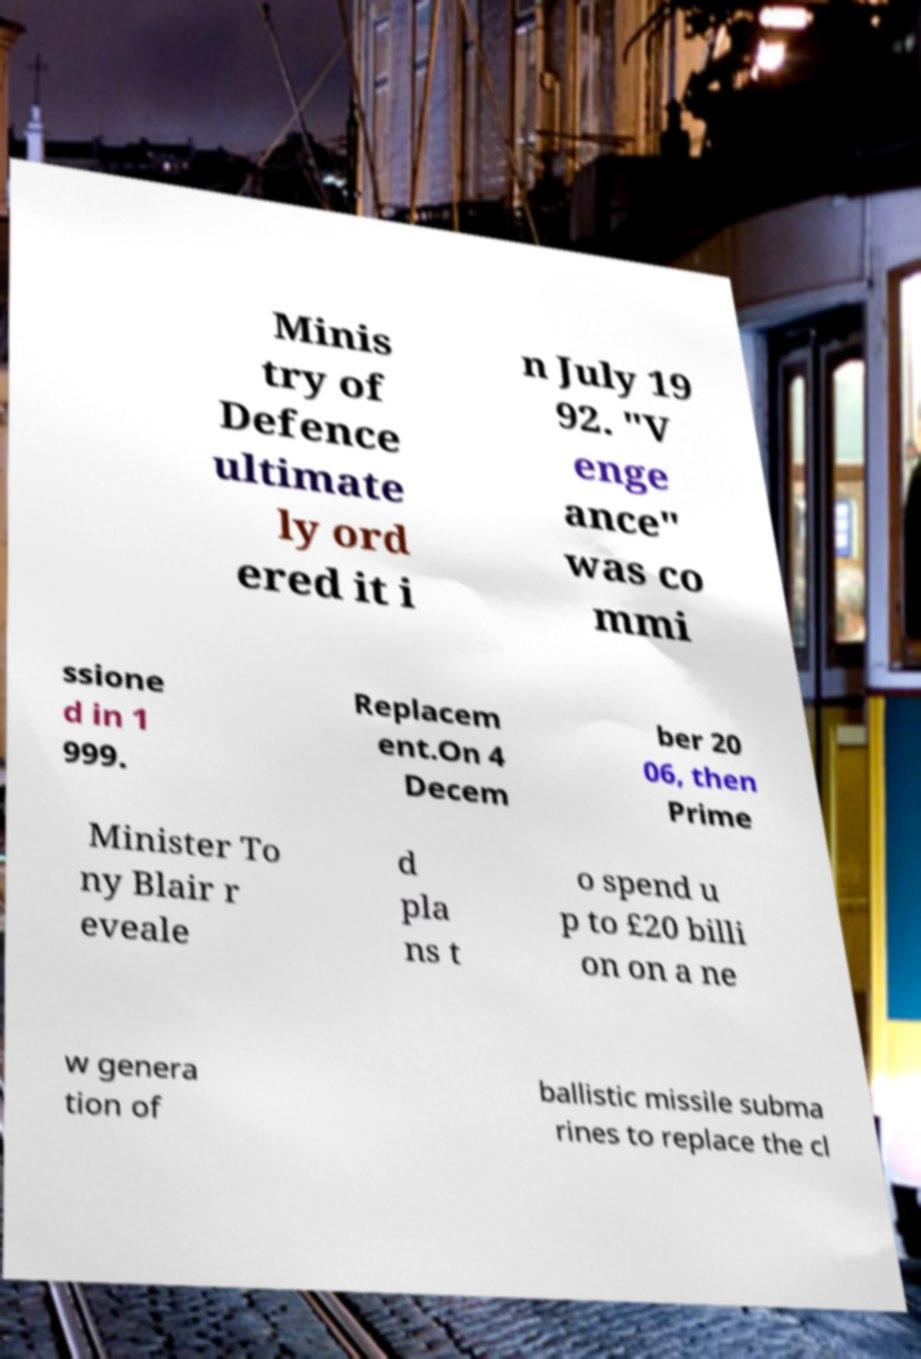Could you extract and type out the text from this image? Minis try of Defence ultimate ly ord ered it i n July 19 92. "V enge ance" was co mmi ssione d in 1 999. Replacem ent.On 4 Decem ber 20 06, then Prime Minister To ny Blair r eveale d pla ns t o spend u p to £20 billi on on a ne w genera tion of ballistic missile subma rines to replace the cl 